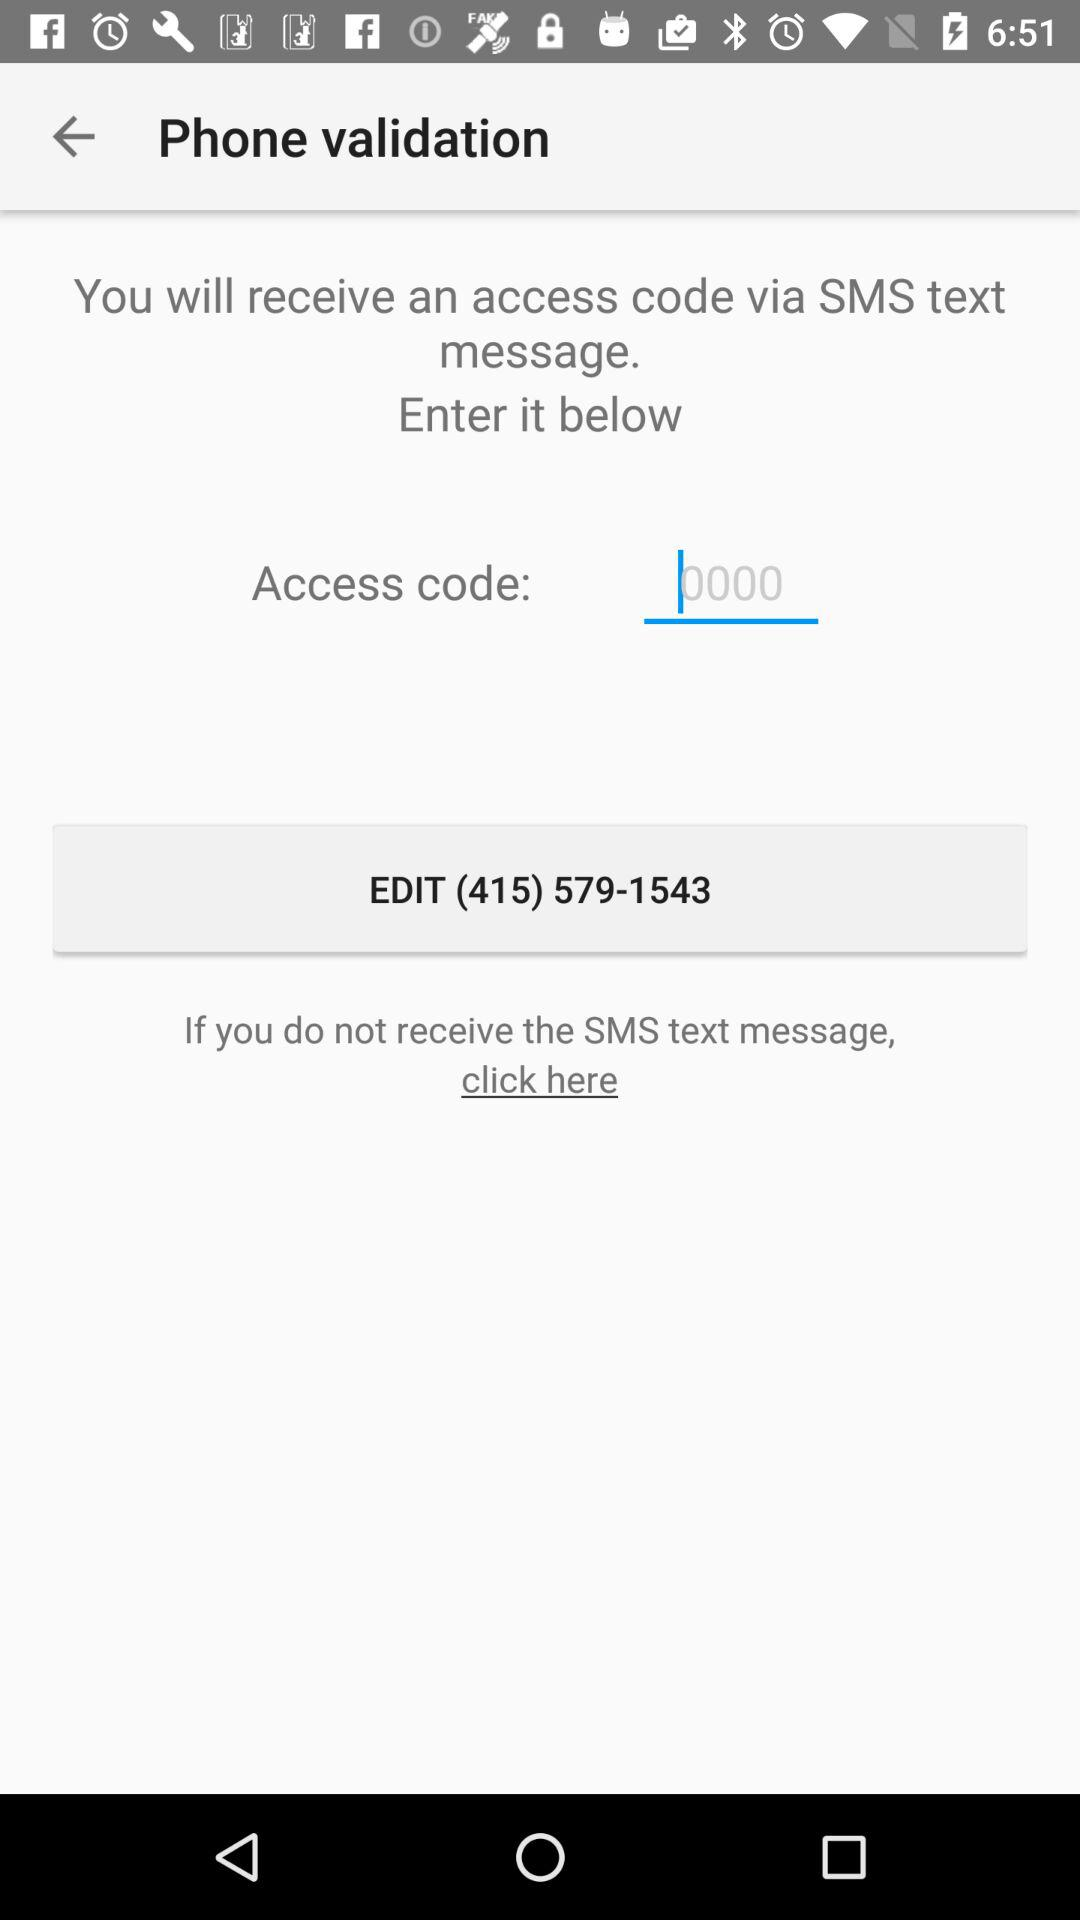How many digits are in the phone number?
Answer the question using a single word or phrase. 10 